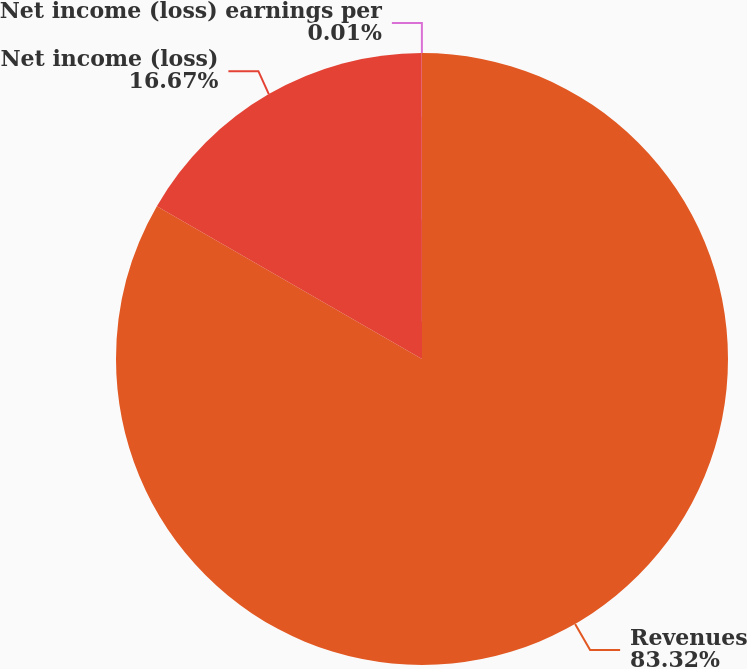<chart> <loc_0><loc_0><loc_500><loc_500><pie_chart><fcel>Revenues<fcel>Net income (loss)<fcel>Net income (loss) earnings per<nl><fcel>83.32%<fcel>16.67%<fcel>0.01%<nl></chart> 